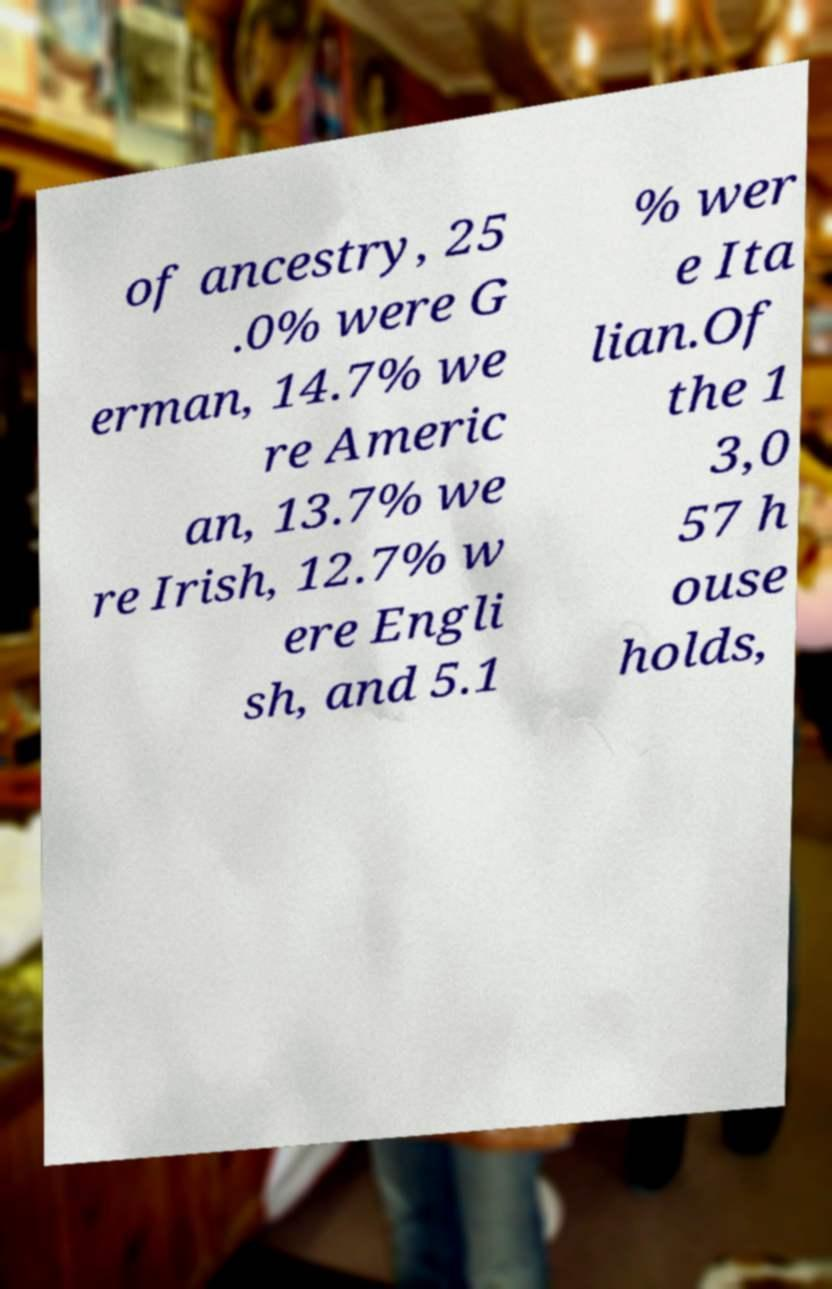Could you extract and type out the text from this image? of ancestry, 25 .0% were G erman, 14.7% we re Americ an, 13.7% we re Irish, 12.7% w ere Engli sh, and 5.1 % wer e Ita lian.Of the 1 3,0 57 h ouse holds, 